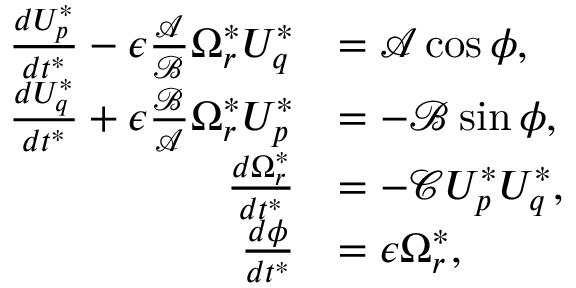<formula> <loc_0><loc_0><loc_500><loc_500>\begin{array} { r l } { \frac { d U _ { p } ^ { * } } { d t ^ { * } } - \epsilon \frac { \mathcal { A } } { \mathcal { B } } \Omega _ { r } ^ { * } U _ { q } ^ { * } } & { = \mathcal { A } \cos \phi , } \\ { \frac { d U _ { q } ^ { * } } { d t ^ { * } } + \epsilon \frac { \mathcal { B } } { \mathcal { A } } \Omega _ { r } ^ { * } U _ { p } ^ { * } } & { = - \mathcal { B } \sin \phi , } \\ { \frac { d \Omega _ { r } ^ { * } } { d t ^ { * } } } & { = - \mathcal { C } U _ { p } ^ { * } U _ { q } ^ { * } , } \\ { \frac { d \phi } { d t ^ { * } } } & { = \epsilon \Omega _ { r } ^ { * } , } \end{array}</formula> 